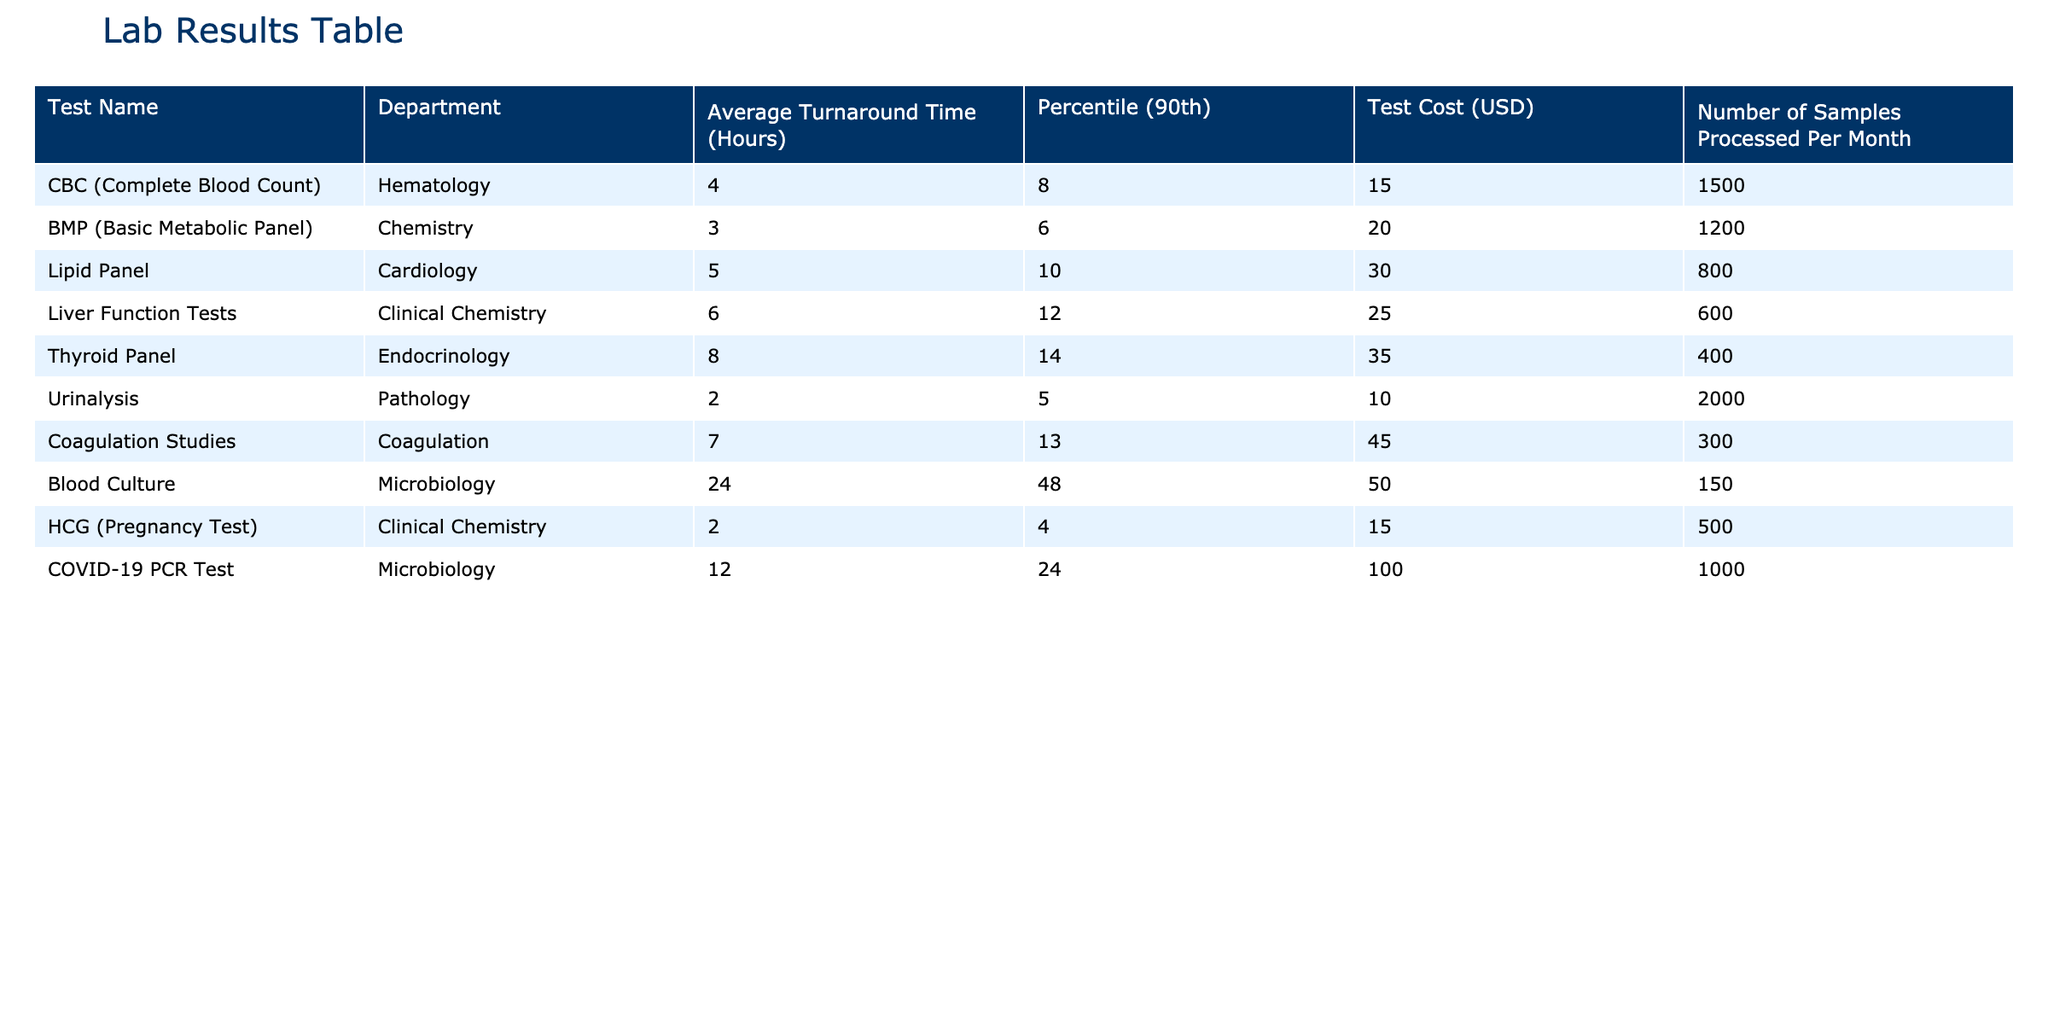What is the average turnaround time for a CBC test? The average turnaround time for a CBC test is specifically listed in the table under the "Average Turnaround Time (Hours)" column, which shows a value of 4 hours.
Answer: 4 hours Which test has the longest average turnaround time? By scanning the "Average Turnaround Time (Hours)" column, the test with the longest turnaround time is the Blood Culture test, which has a value of 24 hours.
Answer: Blood Culture Is the average cost of a Lipid Panel greater than that of a BMP? By comparing the "Test Cost (USD)" for both tests, the Lipid Panel costs 30 USD while the BMP costs 20 USD. Since 30 is greater than 20, the statement is true.
Answer: Yes What is the total number of samples processed for the Coagulation Studies and Blood Culture tests combined per month? The number of samples processed per month for Coagulation Studies is 300 and for Blood Culture it is 150. Adding these numbers together gives 300 + 150 = 450 samples.
Answer: 450 samples What percentage of tests have an average turnaround time greater than 6 hours? The tests with an average turnaround time greater than 6 hours are the Thyroid Panel, Coagulation Studies, and Blood Culture, which total 3 out of 10 tests. To calculate the percentage, use (3/10) * 100 = 30%.
Answer: 30% Which test has the highest cost, and what is that cost? The costs listed across the tests indicate that the COVID-19 PCR Test costs 100 USD, which is the highest.
Answer: 100 USD If the average turnaround time increases by 2 hours for the Liver Function Tests, what will the new average be? The current average turnaround time for Liver Function Tests is 6 hours. If it increases by 2 hours, the new average will be 6 + 2 = 8 hours.
Answer: 8 hours How many tests have an average turnaround time less than 5 hours? Referring to the "Average Turnaround Time (Hours)" column, the tests with average turnaround times less than 5 hours are Urinalysis and HCG, totaling 2 tests.
Answer: 2 tests Is the 90th percentile turnaround time for the Thyroid Panel greater than that of the CBC? The 90th percentile for the Thyroid Panel is 14 hours and for the CBC, it is 8 hours. Since 14 is greater than 8, the statement is true.
Answer: Yes 